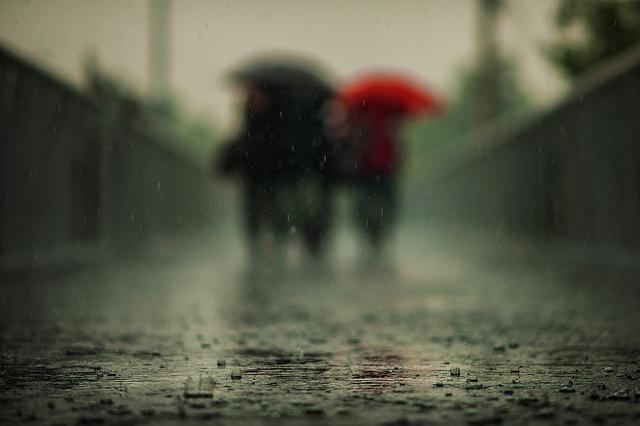How many umbrellas are in the picture?
Give a very brief answer. 2. How many people are there?
Give a very brief answer. 3. How many bicycles are shown?
Give a very brief answer. 0. 